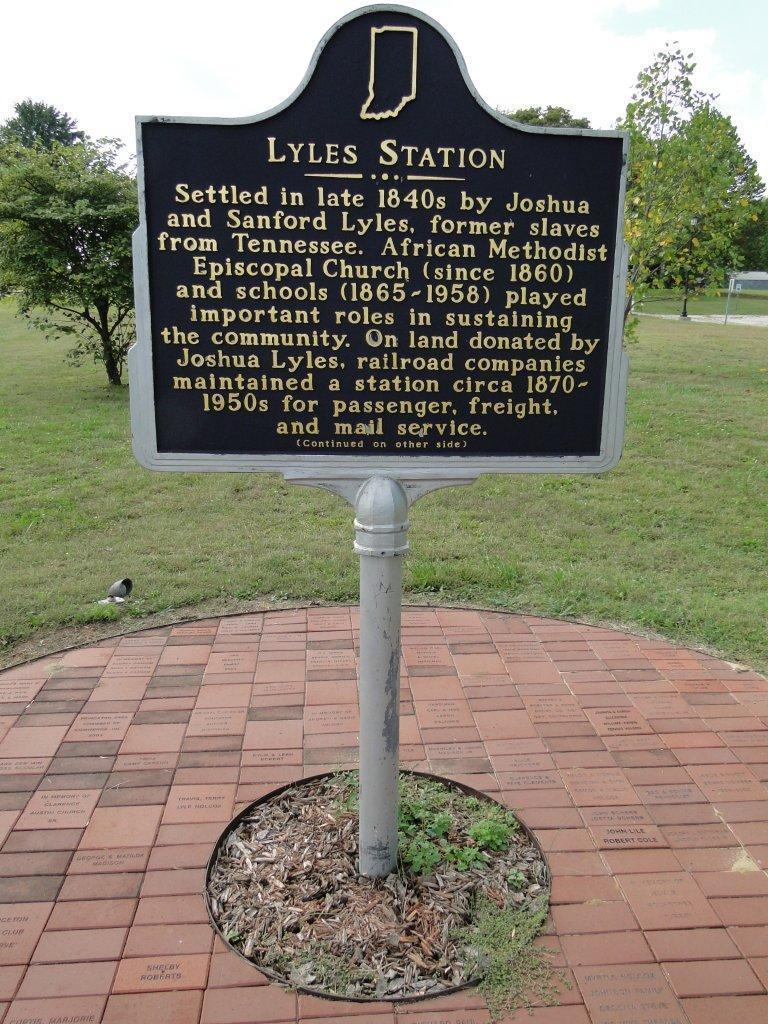What is written on the board in the image? The image contains a board with text, but the specific text is not mentioned in the facts. What type of vegetation is present in the image? There are trees and grass in the image. What animal can be seen in the image? There is a bird in the image. What is visible in the background of the image? The sky is visible in the image. What type of pan is being used by the bird in the image? There is no pan present in the image. 